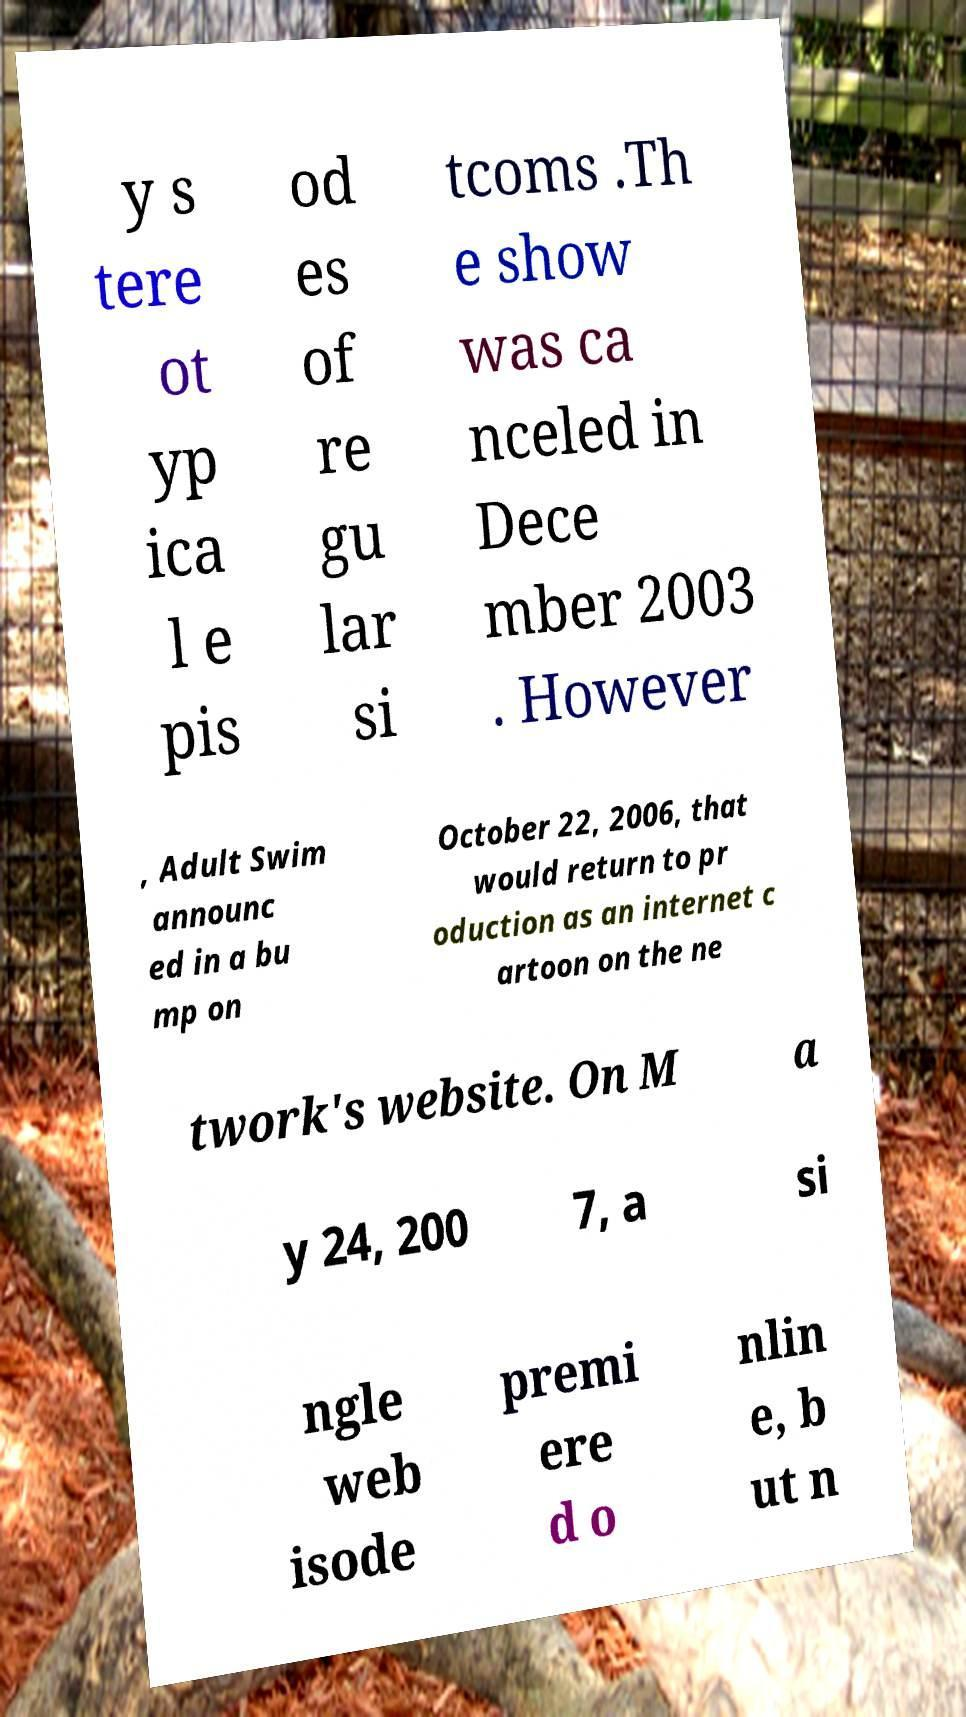Can you accurately transcribe the text from the provided image for me? y s tere ot yp ica l e pis od es of re gu lar si tcoms .Th e show was ca nceled in Dece mber 2003 . However , Adult Swim announc ed in a bu mp on October 22, 2006, that would return to pr oduction as an internet c artoon on the ne twork's website. On M a y 24, 200 7, a si ngle web isode premi ere d o nlin e, b ut n 